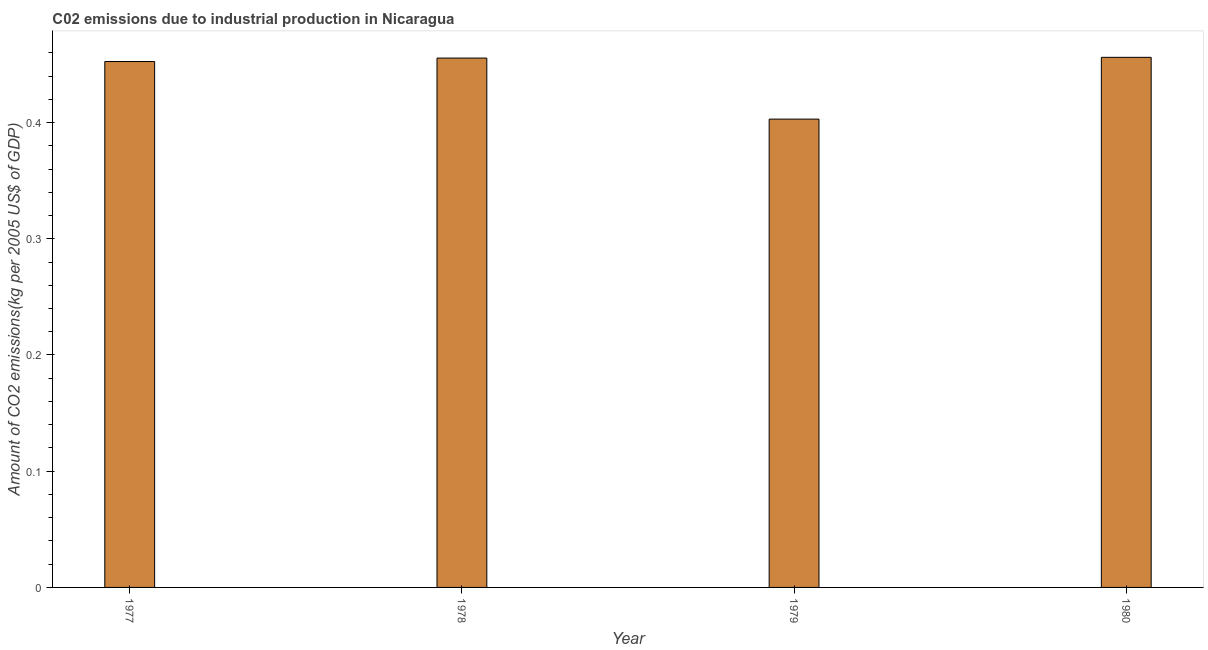Does the graph contain grids?
Give a very brief answer. No. What is the title of the graph?
Your answer should be very brief. C02 emissions due to industrial production in Nicaragua. What is the label or title of the Y-axis?
Ensure brevity in your answer.  Amount of CO2 emissions(kg per 2005 US$ of GDP). What is the amount of co2 emissions in 1979?
Give a very brief answer. 0.4. Across all years, what is the maximum amount of co2 emissions?
Ensure brevity in your answer.  0.46. Across all years, what is the minimum amount of co2 emissions?
Ensure brevity in your answer.  0.4. In which year was the amount of co2 emissions maximum?
Your response must be concise. 1980. In which year was the amount of co2 emissions minimum?
Offer a terse response. 1979. What is the sum of the amount of co2 emissions?
Give a very brief answer. 1.77. What is the difference between the amount of co2 emissions in 1978 and 1980?
Keep it short and to the point. -0. What is the average amount of co2 emissions per year?
Give a very brief answer. 0.44. What is the median amount of co2 emissions?
Your answer should be compact. 0.45. In how many years, is the amount of co2 emissions greater than 0.28 kg per 2005 US$ of GDP?
Offer a very short reply. 4. Do a majority of the years between 1979 and 1980 (inclusive) have amount of co2 emissions greater than 0.12 kg per 2005 US$ of GDP?
Your answer should be very brief. Yes. What is the ratio of the amount of co2 emissions in 1978 to that in 1980?
Provide a succinct answer. 1. What is the difference between the highest and the second highest amount of co2 emissions?
Your answer should be very brief. 0. Is the sum of the amount of co2 emissions in 1979 and 1980 greater than the maximum amount of co2 emissions across all years?
Your answer should be compact. Yes. What is the difference between the highest and the lowest amount of co2 emissions?
Your answer should be very brief. 0.05. What is the difference between two consecutive major ticks on the Y-axis?
Make the answer very short. 0.1. What is the Amount of CO2 emissions(kg per 2005 US$ of GDP) in 1977?
Ensure brevity in your answer.  0.45. What is the Amount of CO2 emissions(kg per 2005 US$ of GDP) in 1978?
Ensure brevity in your answer.  0.46. What is the Amount of CO2 emissions(kg per 2005 US$ of GDP) in 1979?
Keep it short and to the point. 0.4. What is the Amount of CO2 emissions(kg per 2005 US$ of GDP) of 1980?
Give a very brief answer. 0.46. What is the difference between the Amount of CO2 emissions(kg per 2005 US$ of GDP) in 1977 and 1978?
Your response must be concise. -0. What is the difference between the Amount of CO2 emissions(kg per 2005 US$ of GDP) in 1977 and 1979?
Provide a succinct answer. 0.05. What is the difference between the Amount of CO2 emissions(kg per 2005 US$ of GDP) in 1977 and 1980?
Offer a terse response. -0. What is the difference between the Amount of CO2 emissions(kg per 2005 US$ of GDP) in 1978 and 1979?
Provide a short and direct response. 0.05. What is the difference between the Amount of CO2 emissions(kg per 2005 US$ of GDP) in 1978 and 1980?
Keep it short and to the point. -0. What is the difference between the Amount of CO2 emissions(kg per 2005 US$ of GDP) in 1979 and 1980?
Offer a terse response. -0.05. What is the ratio of the Amount of CO2 emissions(kg per 2005 US$ of GDP) in 1977 to that in 1979?
Your answer should be compact. 1.12. What is the ratio of the Amount of CO2 emissions(kg per 2005 US$ of GDP) in 1978 to that in 1979?
Ensure brevity in your answer.  1.13. What is the ratio of the Amount of CO2 emissions(kg per 2005 US$ of GDP) in 1979 to that in 1980?
Make the answer very short. 0.88. 